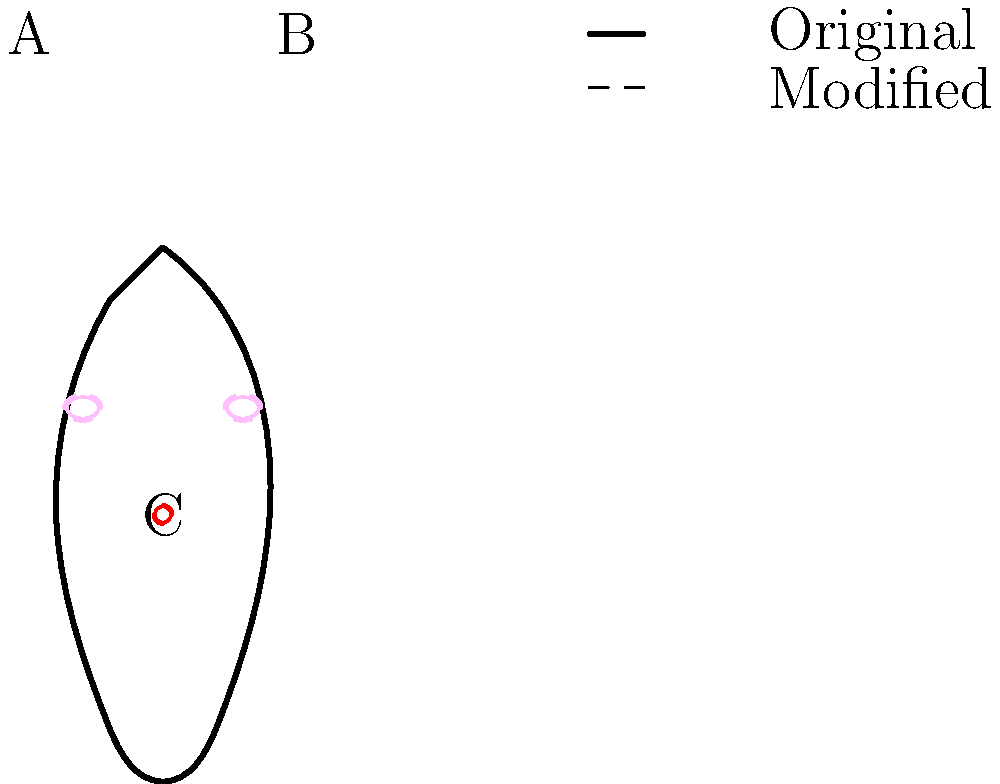Consider the diagram illustrating potential genetic modifications for space travel. Which ethical principle is most challenged by the enhancement of organ B, and what long-term consequence might this have for human evolution in space environments? To answer this question, we need to analyze the ethical implications and potential consequences of genetic modification for space travel:

1. Identify the modified organ: Organ B represents the lungs, which appear enlarged in the modified version.

2. Ethical principles at stake:
   a) Autonomy: The right of individuals to make decisions about their own bodies.
   b) Beneficence: The obligation to provide benefits and balance them against risks.
   c) Non-maleficence: The obligation to avoid causing harm.
   d) Justice: Fair distribution of benefits and risks.

3. The most challenged principle: Non-maleficence
   Rationale: Genetic modification of lungs for space travel involves altering fundamental human biology, which could have unknown long-term effects and potentially cause harm to future generations.

4. Long-term consequences for human evolution:
   a) Adaptation: Enhanced lung capacity could lead to better oxygen utilization in low-oxygen environments.
   b) Genetic drift: Over generations, the modified genes could become more prevalent in space-dwelling populations.
   c) Speciation: Long-term isolation of space colonies with modified genetics could lead to a divergence from Earth-bound humans.
   d) Loss of genetic diversity: If all space travelers have similar genetic modifications, it could reduce overall genetic variability.

5. Key consequence: Potential speciation
   Rationale: The combination of genetic modification and adaptation to space environments could, over many generations, lead to a new branch of human evolution, potentially creating a distinct species adapted for life beyond Earth.
Answer: Non-maleficence; potential speciation of space-dwelling humans 